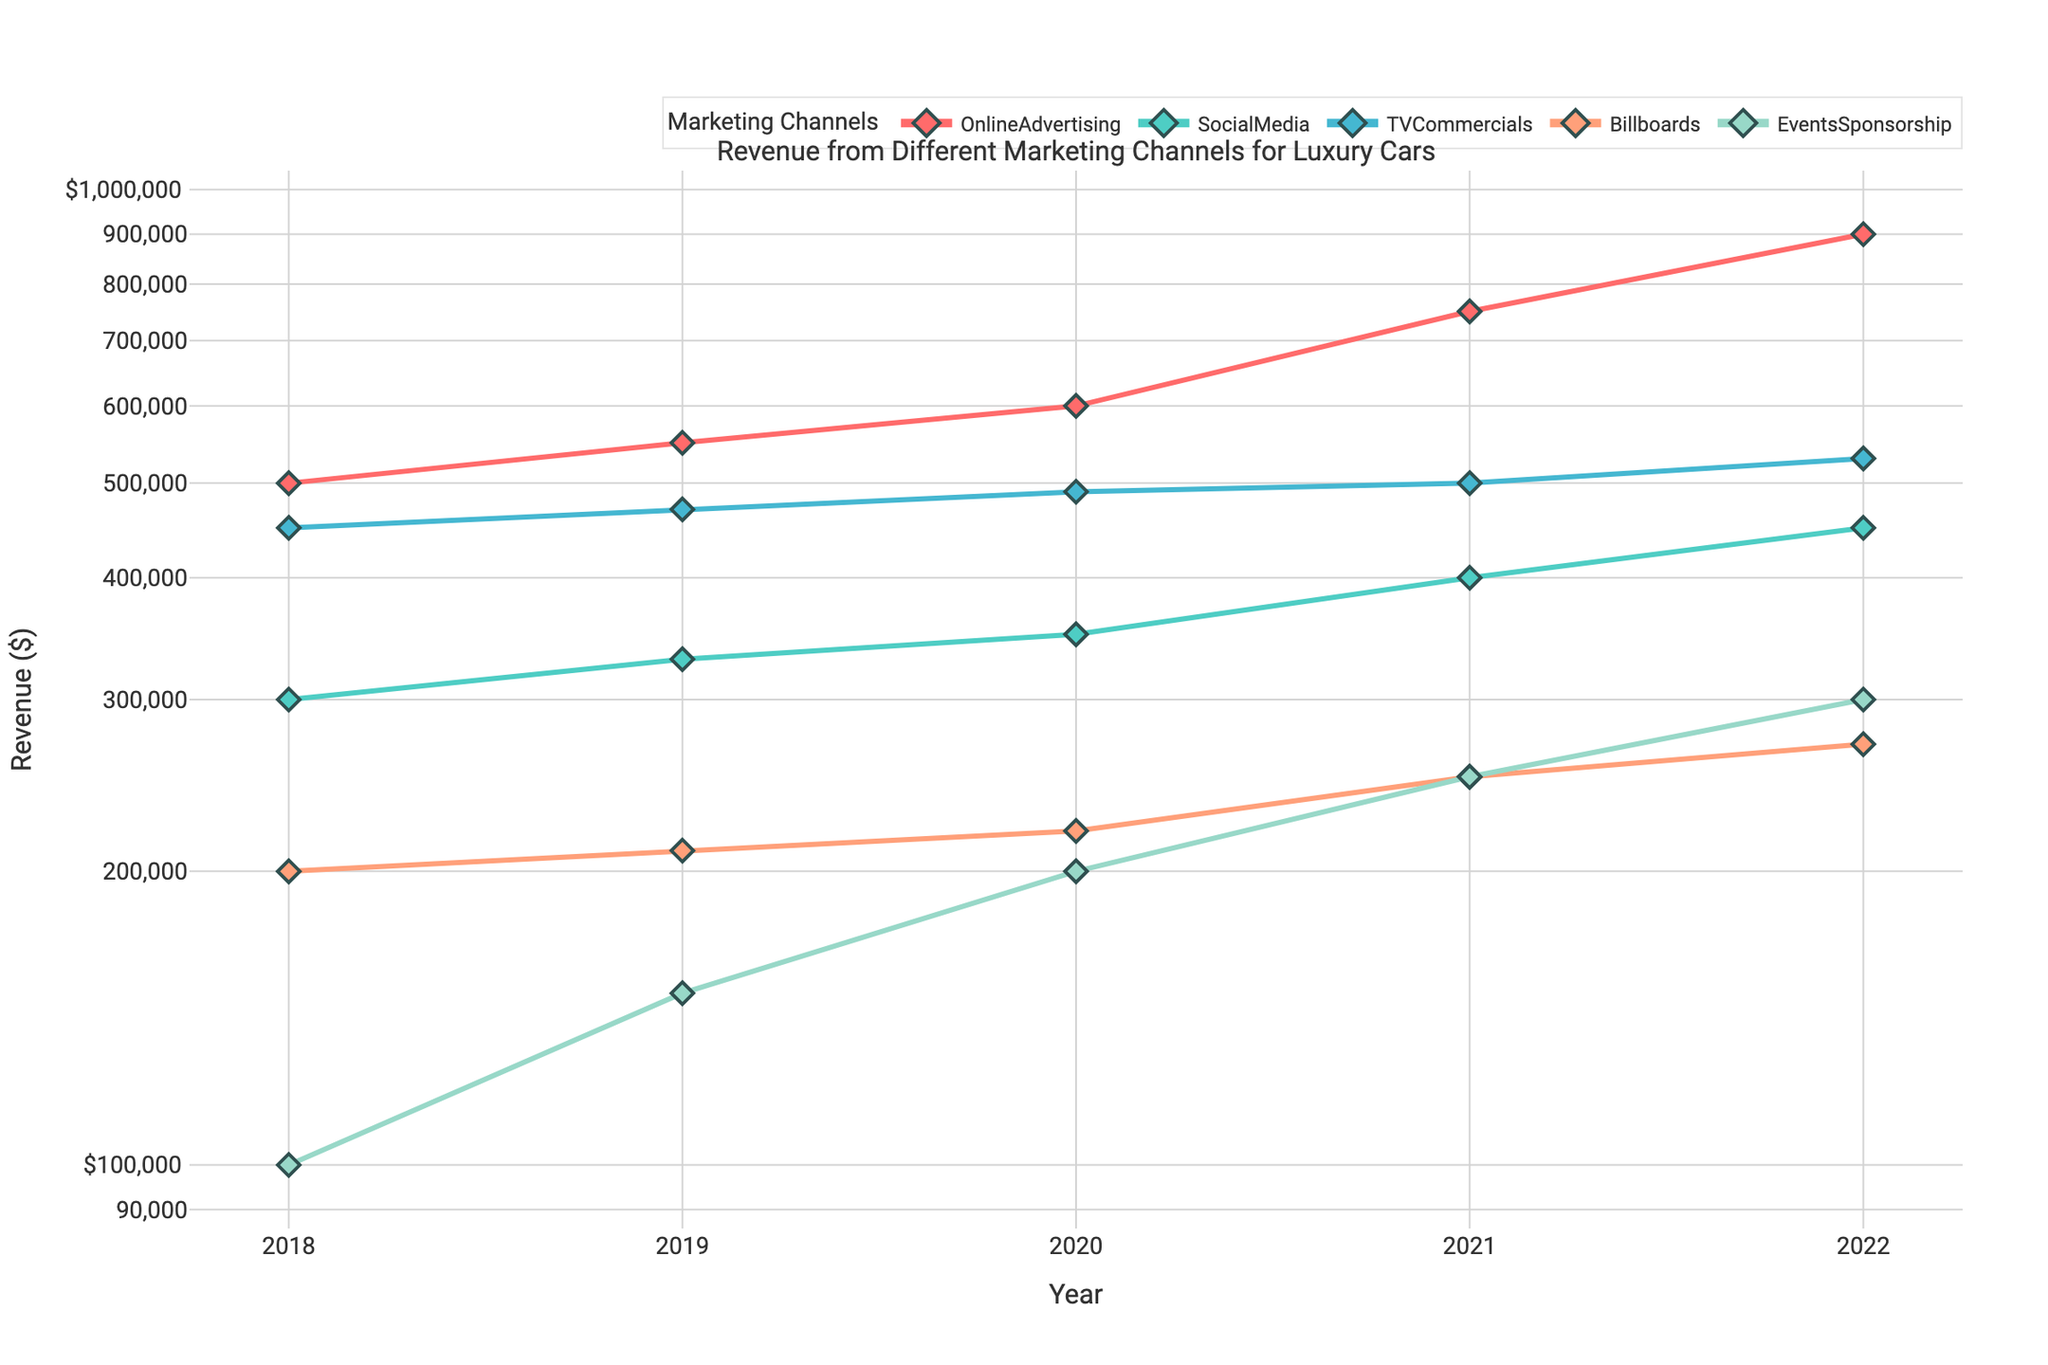What are the marketing channels included in the plot? Identify the names of the marketing channels from the legend of the plot. The channels are listed in the legend section in different colors.
Answer: Online Advertising, Social Media, TV Commercials, Billboards, Events Sponsorship Which year shows the highest revenue for Online Advertising? Identify the line and markers representing Online Advertising, then find the data point with the highest y-value. The year corresponding to the highest point is 2022.
Answer: 2022 What is the revenue from Events Sponsorship in 2021? Locate the line and markers representing Events Sponsorship, and then identify the y-value for the year 2021. The y-value representing the revenue is 250000.
Answer: $250,000 How does the revenue from Social Media in 2019 compare to 2021? Locate and compare the y-values of the Social Media line for the years 2019 and 2021. In 2019, it's 330000 and in 2021, it's 400000. Compare these values to assess that the revenue increased by 70000.
Answer: It increased by $70,000 What is the trend of revenue for TV Commercials over the five years? Follow the line representing TV Commercials from 2018 to 2022, observing whether the revenue generally increases, decreases, or fluctuates. The revenue is consistently increasing each year.
Answer: Increasing Which marketing channel had the least revenue in 2018? Compare the y-values for all marketing channel lines in the year 2018. Identify the lowest value. Events Sponsorship had the lowest revenue.
Answer: Events Sponsorship What is the total revenue for Billboards over the five-year period? Sum the revenues from Billboards for each year (200000 + 210000 + 220000 + 250000 + 270000). The sum equals 1150000.
Answer: $1,150,000 How did the growth in revenue for Online Advertising from 2020 to 2021 compare to that from 2021 to 2022? Calculate the difference in revenue for Online Advertising between 2021 and 2020, which is 150000, and the difference between 2022 and 2021, which is also 150000. Compare these differences to find they are equal.
Answer: The growth rates are equal Which marketing channel had the most consistent growth over the five years? Assess the trends and consistency of the lines representing each marketing channel. Social Media shows the most consistent growth with a smooth upward trend.
Answer: Social Media In 2020, which channel had higher revenue, TV Commercials or Social Media? Compare the y-values for TV Commercials and Social Media for 2020. TV Commercials had a revenue of 490000, whereas Social Media had 350000. Hence, TV Commercials had higher revenue.
Answer: TV Commercials 